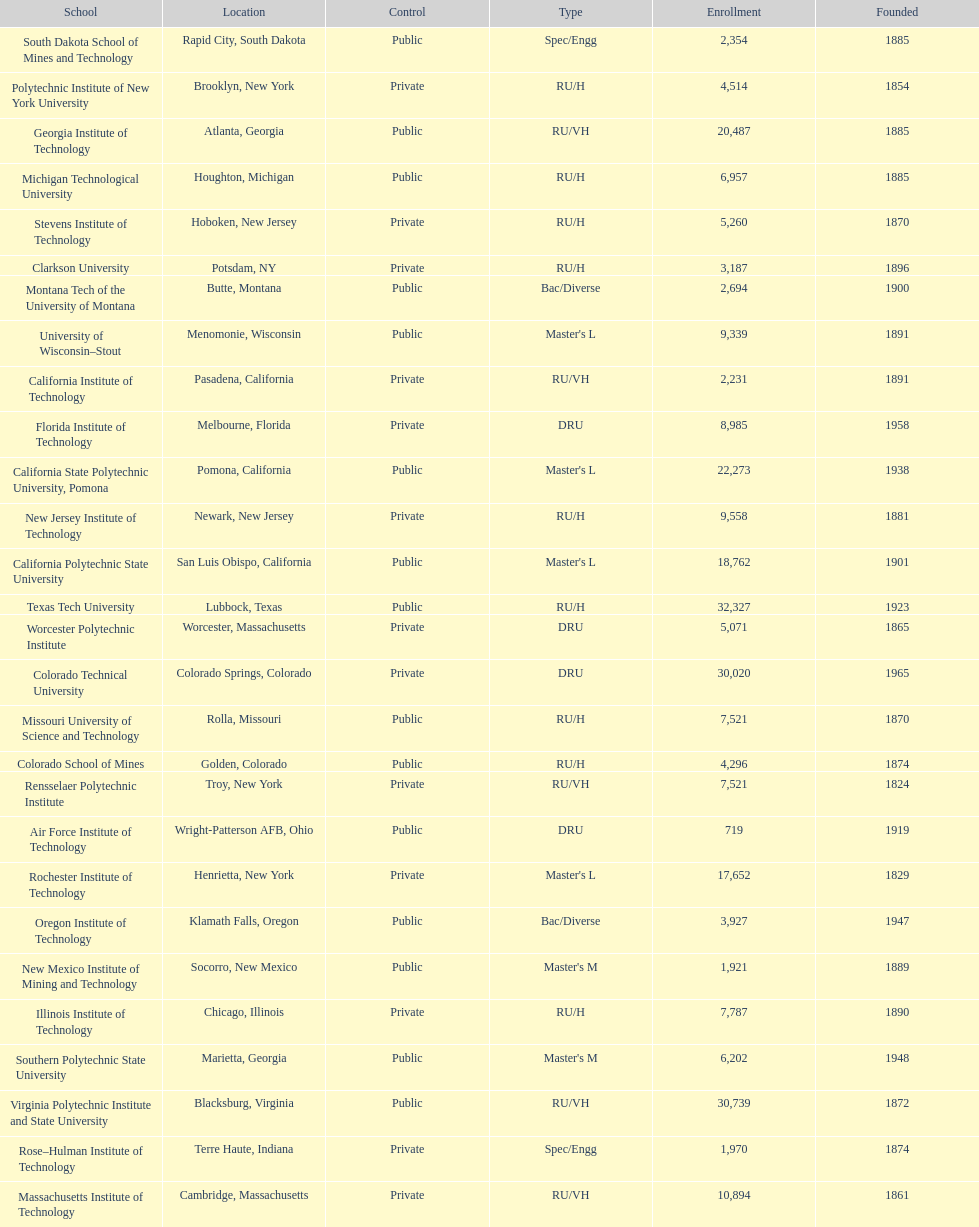What is the number of us technological schools in the state of california? 3. 